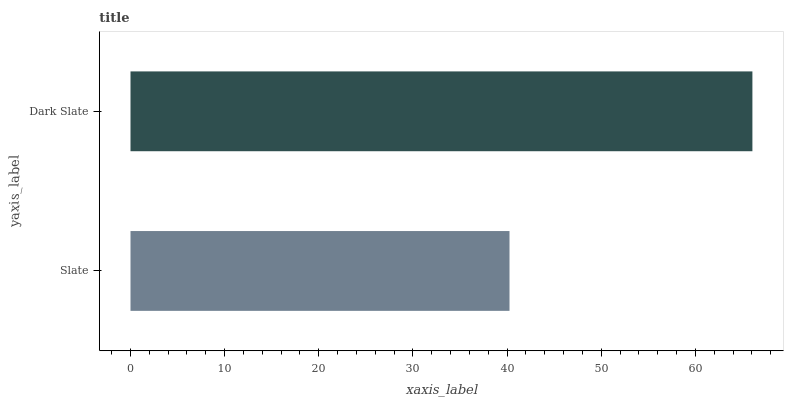Is Slate the minimum?
Answer yes or no. Yes. Is Dark Slate the maximum?
Answer yes or no. Yes. Is Dark Slate the minimum?
Answer yes or no. No. Is Dark Slate greater than Slate?
Answer yes or no. Yes. Is Slate less than Dark Slate?
Answer yes or no. Yes. Is Slate greater than Dark Slate?
Answer yes or no. No. Is Dark Slate less than Slate?
Answer yes or no. No. Is Dark Slate the high median?
Answer yes or no. Yes. Is Slate the low median?
Answer yes or no. Yes. Is Slate the high median?
Answer yes or no. No. Is Dark Slate the low median?
Answer yes or no. No. 